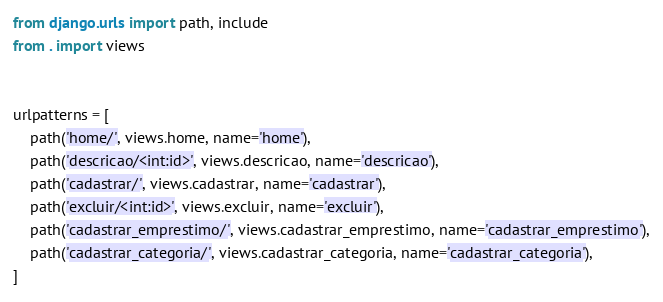<code> <loc_0><loc_0><loc_500><loc_500><_Python_>from django.urls import path, include
from . import views


urlpatterns = [
    path('home/', views.home, name='home'),
    path('descricao/<int:id>', views.descricao, name='descricao'),
    path('cadastrar/', views.cadastrar, name='cadastrar'),
    path('excluir/<int:id>', views.excluir, name='excluir'),
    path('cadastrar_emprestimo/', views.cadastrar_emprestimo, name='cadastrar_emprestimo'),
    path('cadastrar_categoria/', views.cadastrar_categoria, name='cadastrar_categoria'),
]</code> 